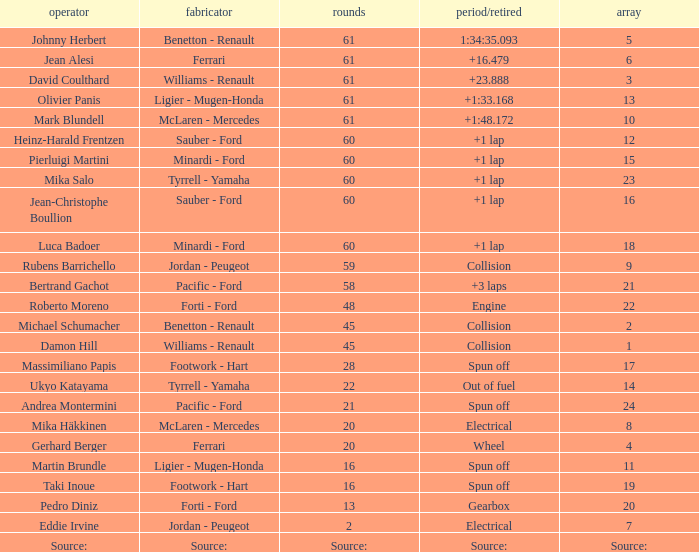Parse the full table. {'header': ['operator', 'fabricator', 'rounds', 'period/retired', 'array'], 'rows': [['Johnny Herbert', 'Benetton - Renault', '61', '1:34:35.093', '5'], ['Jean Alesi', 'Ferrari', '61', '+16.479', '6'], ['David Coulthard', 'Williams - Renault', '61', '+23.888', '3'], ['Olivier Panis', 'Ligier - Mugen-Honda', '61', '+1:33.168', '13'], ['Mark Blundell', 'McLaren - Mercedes', '61', '+1:48.172', '10'], ['Heinz-Harald Frentzen', 'Sauber - Ford', '60', '+1 lap', '12'], ['Pierluigi Martini', 'Minardi - Ford', '60', '+1 lap', '15'], ['Mika Salo', 'Tyrrell - Yamaha', '60', '+1 lap', '23'], ['Jean-Christophe Boullion', 'Sauber - Ford', '60', '+1 lap', '16'], ['Luca Badoer', 'Minardi - Ford', '60', '+1 lap', '18'], ['Rubens Barrichello', 'Jordan - Peugeot', '59', 'Collision', '9'], ['Bertrand Gachot', 'Pacific - Ford', '58', '+3 laps', '21'], ['Roberto Moreno', 'Forti - Ford', '48', 'Engine', '22'], ['Michael Schumacher', 'Benetton - Renault', '45', 'Collision', '2'], ['Damon Hill', 'Williams - Renault', '45', 'Collision', '1'], ['Massimiliano Papis', 'Footwork - Hart', '28', 'Spun off', '17'], ['Ukyo Katayama', 'Tyrrell - Yamaha', '22', 'Out of fuel', '14'], ['Andrea Montermini', 'Pacific - Ford', '21', 'Spun off', '24'], ['Mika Häkkinen', 'McLaren - Mercedes', '20', 'Electrical', '8'], ['Gerhard Berger', 'Ferrari', '20', 'Wheel', '4'], ['Martin Brundle', 'Ligier - Mugen-Honda', '16', 'Spun off', '11'], ['Taki Inoue', 'Footwork - Hart', '16', 'Spun off', '19'], ['Pedro Diniz', 'Forti - Ford', '13', 'Gearbox', '20'], ['Eddie Irvine', 'Jordan - Peugeot', '2', 'Electrical', '7'], ['Source:', 'Source:', 'Source:', 'Source:', 'Source:']]} How many laps does jean-christophe boullion have with a time/retired of +1 lap? 60.0. 